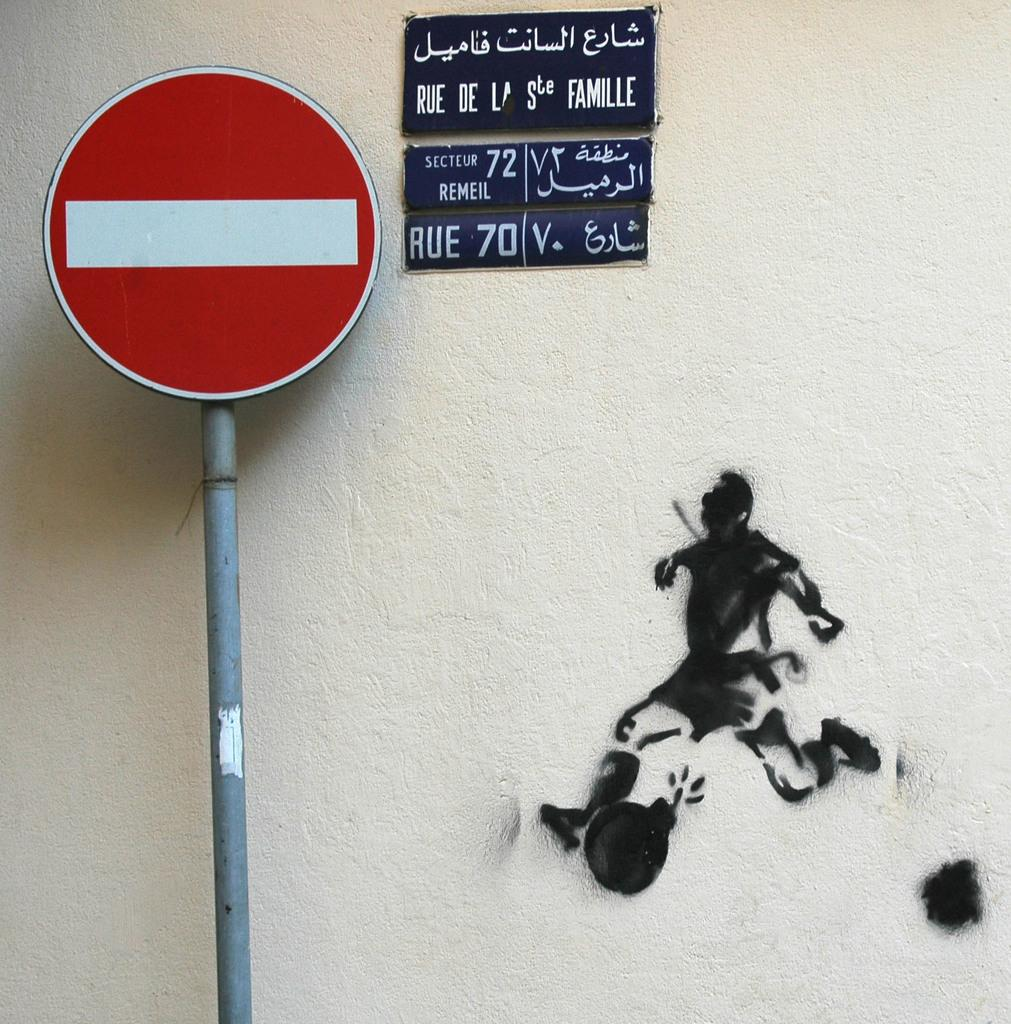<image>
Create a compact narrative representing the image presented. a do not enter sign with a smaller sign in a foreign language at the right of it and a picture of a man running towards the sign. 